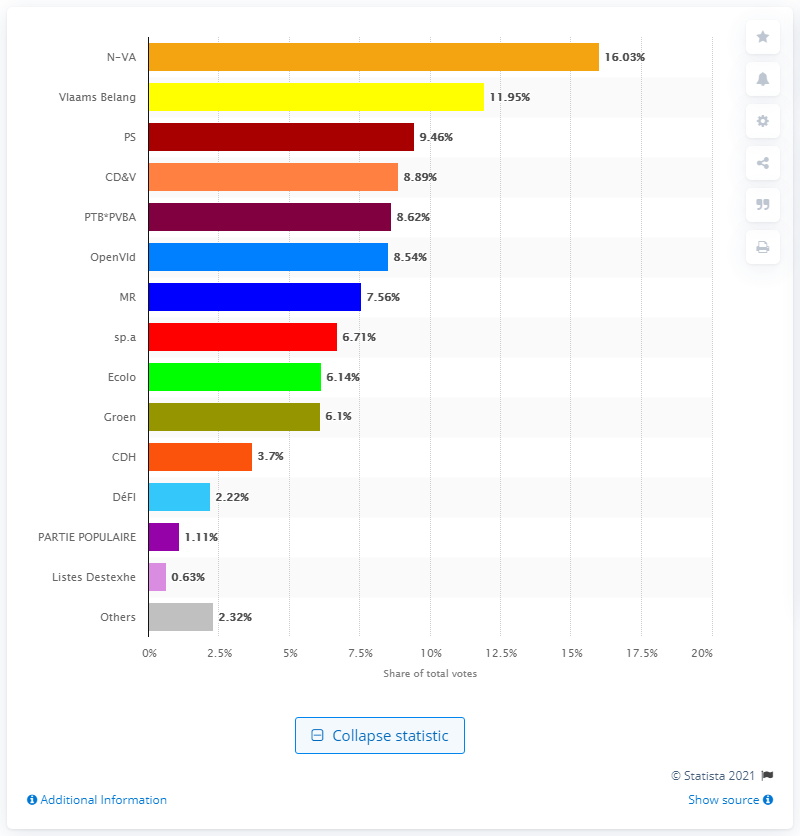List a handful of essential elements in this visual. The French-speaking socialist party received 9.46% of the total votes cast. The name of the Flemish nationalist party is N-VA. 